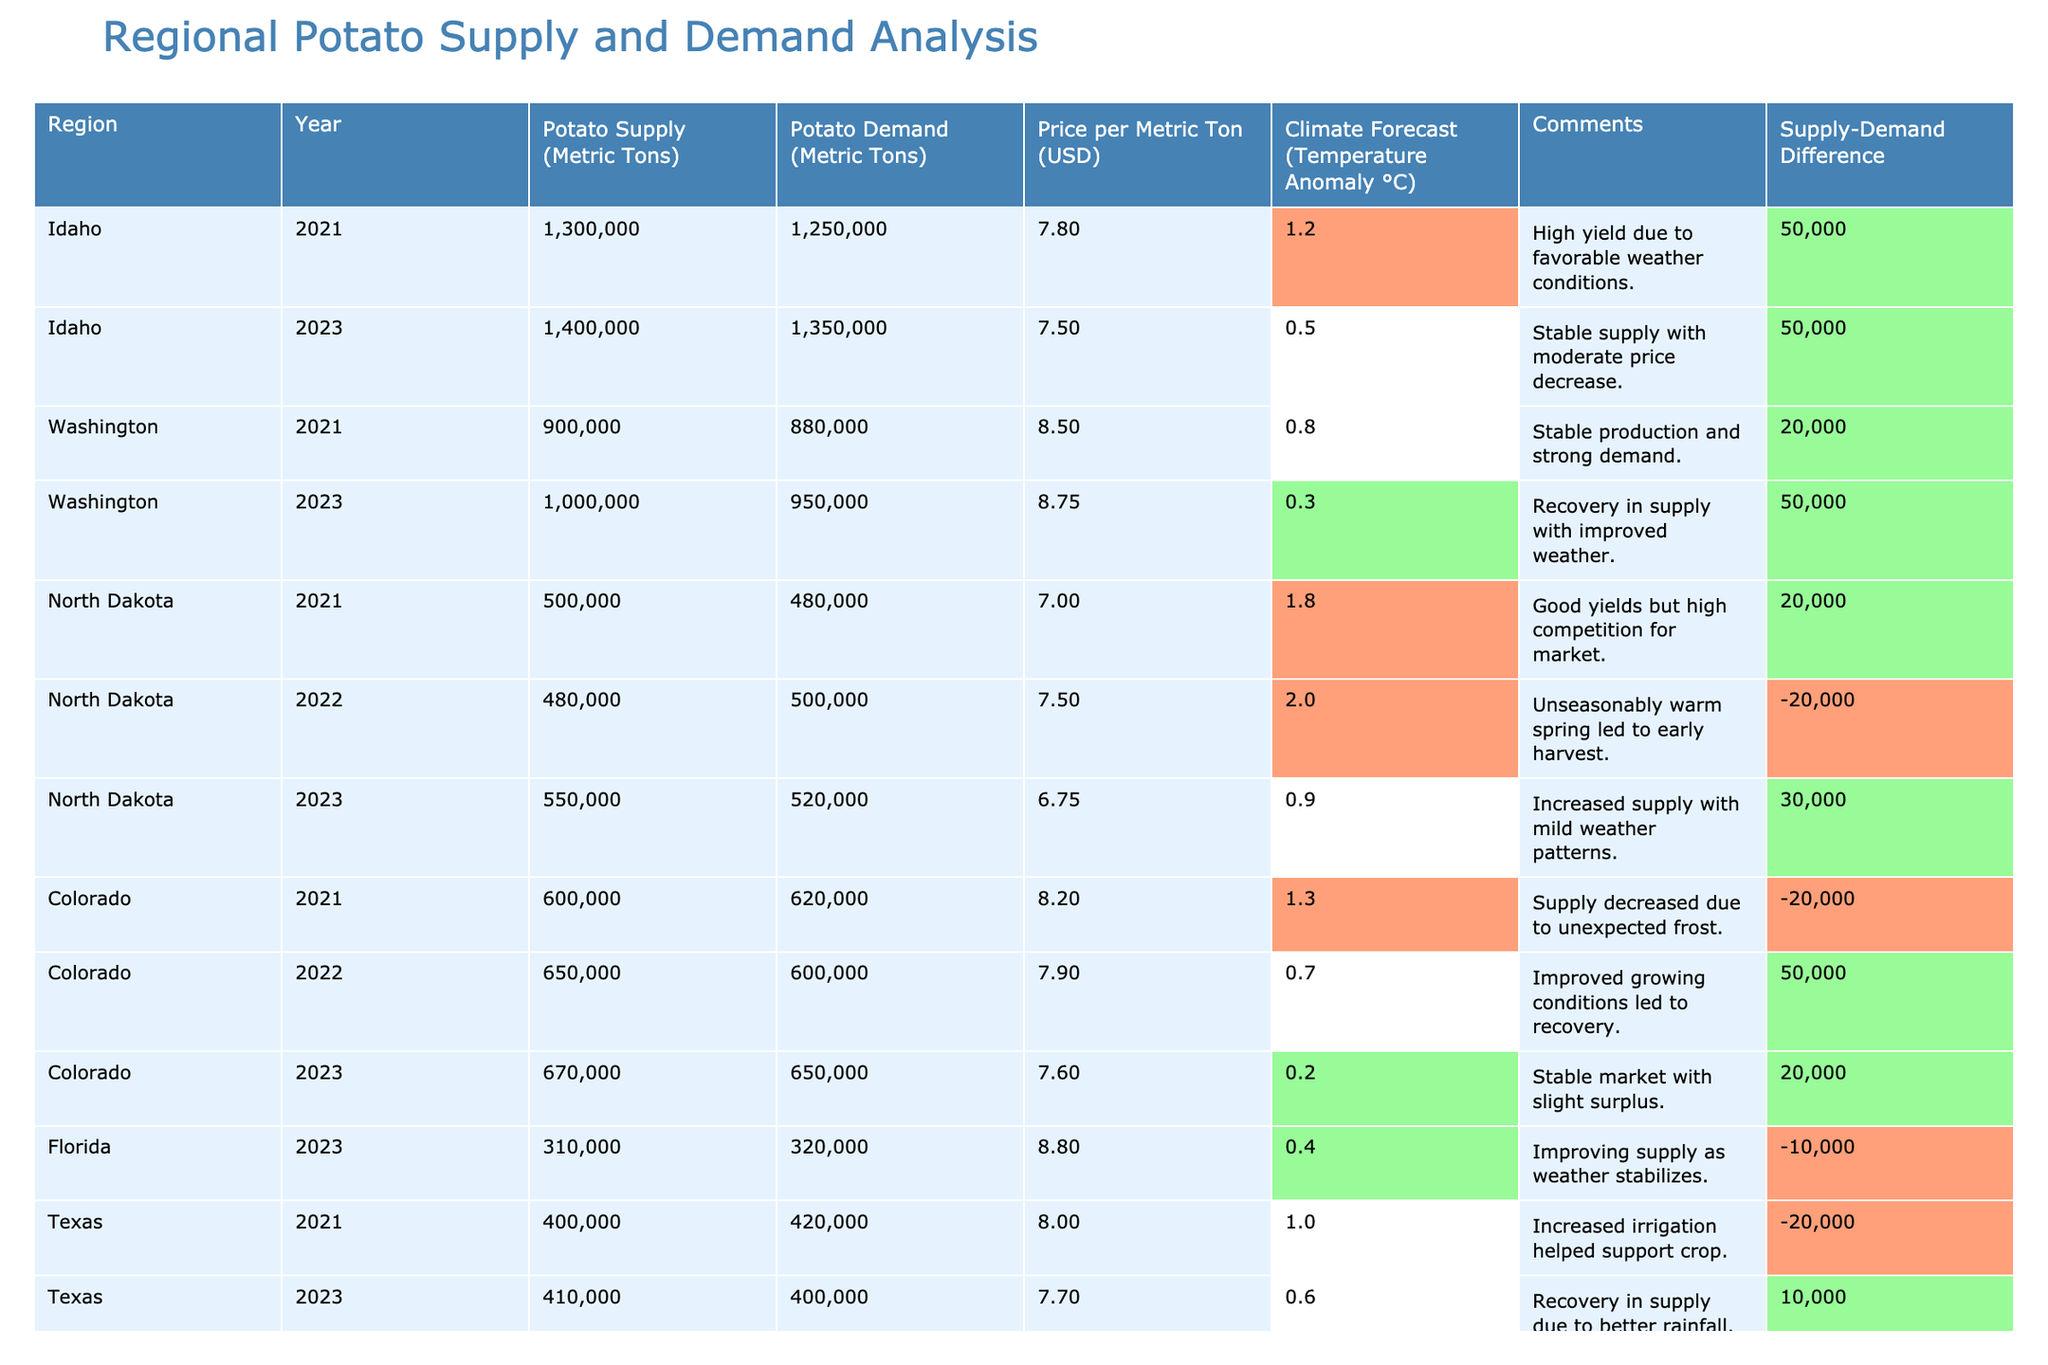What is the potato supply in Idaho for the year 2023? The table shows that for Idaho in the year 2023, the potato supply is listed as 1,400,000 metric tons.
Answer: 1,400,000 metric tons What is the price per metric ton of potatoes in North Dakota for 2022? According to the table, the price per metric ton in North Dakota for the year 2022 is indicated as 7.50 USD.
Answer: 7.50 USD Is the potato demand higher or lower than supply in Colorado for 2023? In Colorado for the year 2023, the potato supply is 670,000 metric tons, and the demand is 650,000 metric tons. Since supply is greater than demand, the answer is that demand is lower.
Answer: Lower What was the climate forecast (temperature anomaly) for Washington in 2021? The table states that for Washington in 2021, the climate forecast (temperature anomaly) was 0.8°C.
Answer: 0.8°C Which region had the highest potato supply in 2021? By comparing the potato supply values for each region in 2021, Idaho has the highest supply with 1,300,000 metric tons.
Answer: Idaho What is the average potato price per metric ton for Idaho across the years present in the table? For Idaho, the prices per metric ton are 7.80 USD for 2021 and 7.50 USD for 2023. The average is (7.80 + 7.50) / 2 = 7.65 USD.
Answer: 7.65 USD Did potato supply increase in North Dakota from 2021 to 2023? The supply in North Dakota was 500,000 metric tons in 2021 and increased to 550,000 metric tons in 2023. Thus, the supply did indeed increase.
Answer: Yes What is the total potato supply across all regions in 2023? Adding the potato supplies for 2023: Idaho (1,400,000) + Washington (1,000,000) + North Dakota (550,000) + Colorado (670,000) + Florida (310,000) + Texas (410,000) totals 4,340,000 metric tons.
Answer: 4,340,000 metric tons What was the supply-demand difference for potatoes in Colorado for 2023? In Colorado for 2023, the potato supply is 670,000 metric tons and the demand is 650,000 metric tons. The difference is calculated as 670,000 - 650,000 = 20,000 metric tons.
Answer: 20,000 metric tons 